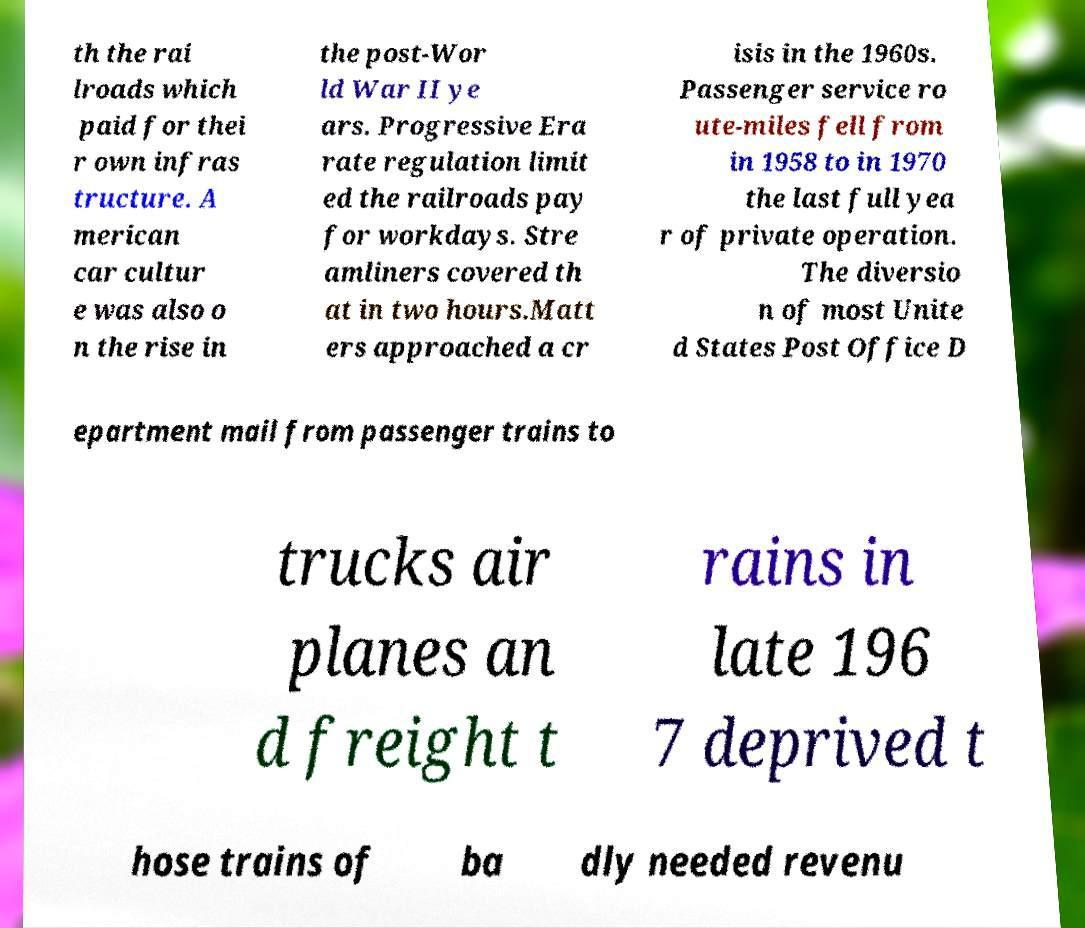Please read and relay the text visible in this image. What does it say? th the rai lroads which paid for thei r own infras tructure. A merican car cultur e was also o n the rise in the post-Wor ld War II ye ars. Progressive Era rate regulation limit ed the railroads pay for workdays. Stre amliners covered th at in two hours.Matt ers approached a cr isis in the 1960s. Passenger service ro ute-miles fell from in 1958 to in 1970 the last full yea r of private operation. The diversio n of most Unite d States Post Office D epartment mail from passenger trains to trucks air planes an d freight t rains in late 196 7 deprived t hose trains of ba dly needed revenu 